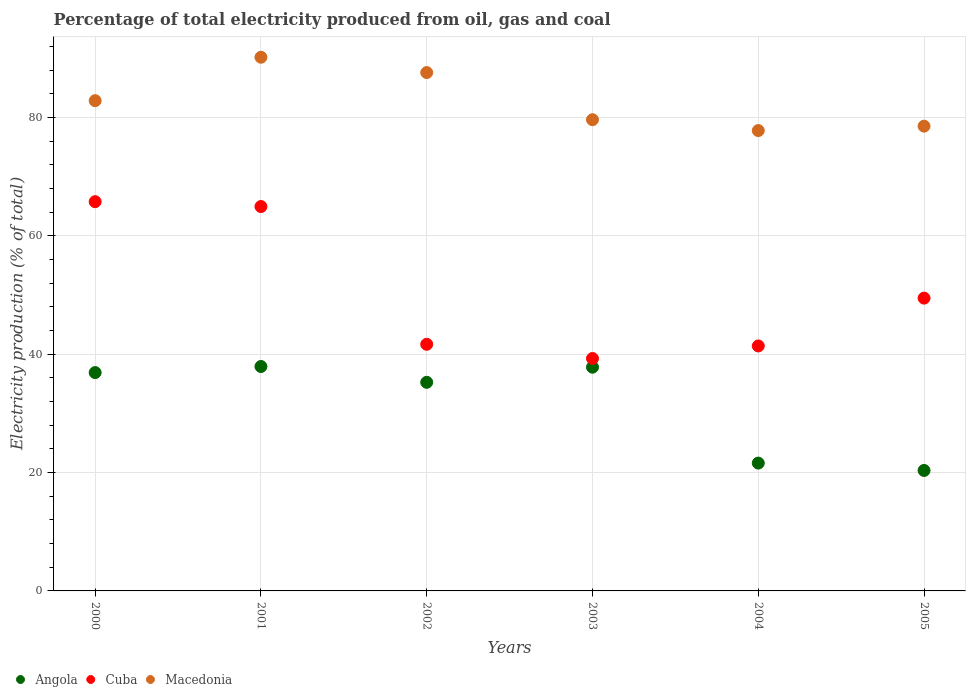How many different coloured dotlines are there?
Give a very brief answer. 3. Is the number of dotlines equal to the number of legend labels?
Make the answer very short. Yes. What is the electricity production in in Macedonia in 2001?
Provide a short and direct response. 90.16. Across all years, what is the maximum electricity production in in Cuba?
Provide a short and direct response. 65.76. Across all years, what is the minimum electricity production in in Cuba?
Make the answer very short. 39.27. In which year was the electricity production in in Cuba maximum?
Offer a terse response. 2000. What is the total electricity production in in Macedonia in the graph?
Offer a terse response. 496.45. What is the difference between the electricity production in in Angola in 2000 and that in 2005?
Provide a succinct answer. 16.53. What is the difference between the electricity production in in Cuba in 2001 and the electricity production in in Macedonia in 2000?
Keep it short and to the point. -17.88. What is the average electricity production in in Angola per year?
Ensure brevity in your answer.  31.63. In the year 2001, what is the difference between the electricity production in in Angola and electricity production in in Cuba?
Make the answer very short. -27.03. In how many years, is the electricity production in in Macedonia greater than 52 %?
Your answer should be very brief. 6. What is the ratio of the electricity production in in Cuba in 2001 to that in 2003?
Give a very brief answer. 1.65. Is the difference between the electricity production in in Angola in 2001 and 2005 greater than the difference between the electricity production in in Cuba in 2001 and 2005?
Ensure brevity in your answer.  Yes. What is the difference between the highest and the second highest electricity production in in Macedonia?
Give a very brief answer. 2.59. What is the difference between the highest and the lowest electricity production in in Macedonia?
Keep it short and to the point. 12.39. Is the sum of the electricity production in in Cuba in 2000 and 2004 greater than the maximum electricity production in in Angola across all years?
Your response must be concise. Yes. Does the electricity production in in Cuba monotonically increase over the years?
Ensure brevity in your answer.  No. Where does the legend appear in the graph?
Provide a short and direct response. Bottom left. How many legend labels are there?
Provide a short and direct response. 3. How are the legend labels stacked?
Offer a terse response. Horizontal. What is the title of the graph?
Make the answer very short. Percentage of total electricity produced from oil, gas and coal. Does "Zambia" appear as one of the legend labels in the graph?
Your response must be concise. No. What is the label or title of the Y-axis?
Your answer should be very brief. Electricity production (% of total). What is the Electricity production (% of total) in Angola in 2000?
Provide a short and direct response. 36.89. What is the Electricity production (% of total) in Cuba in 2000?
Ensure brevity in your answer.  65.76. What is the Electricity production (% of total) of Macedonia in 2000?
Ensure brevity in your answer.  82.82. What is the Electricity production (% of total) in Angola in 2001?
Your answer should be compact. 37.91. What is the Electricity production (% of total) in Cuba in 2001?
Offer a terse response. 64.94. What is the Electricity production (% of total) of Macedonia in 2001?
Your answer should be very brief. 90.16. What is the Electricity production (% of total) in Angola in 2002?
Keep it short and to the point. 35.24. What is the Electricity production (% of total) of Cuba in 2002?
Ensure brevity in your answer.  41.67. What is the Electricity production (% of total) in Macedonia in 2002?
Give a very brief answer. 87.57. What is the Electricity production (% of total) in Angola in 2003?
Your response must be concise. 37.79. What is the Electricity production (% of total) in Cuba in 2003?
Offer a very short reply. 39.27. What is the Electricity production (% of total) of Macedonia in 2003?
Offer a terse response. 79.61. What is the Electricity production (% of total) in Angola in 2004?
Provide a succinct answer. 21.59. What is the Electricity production (% of total) in Cuba in 2004?
Offer a very short reply. 41.38. What is the Electricity production (% of total) in Macedonia in 2004?
Offer a terse response. 77.77. What is the Electricity production (% of total) in Angola in 2005?
Offer a terse response. 20.35. What is the Electricity production (% of total) of Cuba in 2005?
Offer a terse response. 49.47. What is the Electricity production (% of total) in Macedonia in 2005?
Your answer should be compact. 78.52. Across all years, what is the maximum Electricity production (% of total) of Angola?
Provide a succinct answer. 37.91. Across all years, what is the maximum Electricity production (% of total) of Cuba?
Ensure brevity in your answer.  65.76. Across all years, what is the maximum Electricity production (% of total) in Macedonia?
Make the answer very short. 90.16. Across all years, what is the minimum Electricity production (% of total) of Angola?
Keep it short and to the point. 20.35. Across all years, what is the minimum Electricity production (% of total) of Cuba?
Your answer should be compact. 39.27. Across all years, what is the minimum Electricity production (% of total) of Macedonia?
Offer a terse response. 77.77. What is the total Electricity production (% of total) of Angola in the graph?
Offer a very short reply. 189.78. What is the total Electricity production (% of total) of Cuba in the graph?
Offer a very short reply. 302.48. What is the total Electricity production (% of total) of Macedonia in the graph?
Make the answer very short. 496.45. What is the difference between the Electricity production (% of total) of Angola in 2000 and that in 2001?
Provide a succinct answer. -1.03. What is the difference between the Electricity production (% of total) in Cuba in 2000 and that in 2001?
Keep it short and to the point. 0.82. What is the difference between the Electricity production (% of total) in Macedonia in 2000 and that in 2001?
Give a very brief answer. -7.34. What is the difference between the Electricity production (% of total) of Angola in 2000 and that in 2002?
Provide a short and direct response. 1.65. What is the difference between the Electricity production (% of total) of Cuba in 2000 and that in 2002?
Your answer should be very brief. 24.09. What is the difference between the Electricity production (% of total) in Macedonia in 2000 and that in 2002?
Ensure brevity in your answer.  -4.75. What is the difference between the Electricity production (% of total) in Angola in 2000 and that in 2003?
Give a very brief answer. -0.91. What is the difference between the Electricity production (% of total) in Cuba in 2000 and that in 2003?
Your answer should be compact. 26.49. What is the difference between the Electricity production (% of total) of Macedonia in 2000 and that in 2003?
Ensure brevity in your answer.  3.21. What is the difference between the Electricity production (% of total) in Angola in 2000 and that in 2004?
Your response must be concise. 15.29. What is the difference between the Electricity production (% of total) of Cuba in 2000 and that in 2004?
Offer a very short reply. 24.38. What is the difference between the Electricity production (% of total) in Macedonia in 2000 and that in 2004?
Keep it short and to the point. 5.05. What is the difference between the Electricity production (% of total) in Angola in 2000 and that in 2005?
Your response must be concise. 16.53. What is the difference between the Electricity production (% of total) in Cuba in 2000 and that in 2005?
Provide a succinct answer. 16.29. What is the difference between the Electricity production (% of total) in Macedonia in 2000 and that in 2005?
Keep it short and to the point. 4.3. What is the difference between the Electricity production (% of total) in Angola in 2001 and that in 2002?
Keep it short and to the point. 2.67. What is the difference between the Electricity production (% of total) in Cuba in 2001 and that in 2002?
Provide a short and direct response. 23.27. What is the difference between the Electricity production (% of total) in Macedonia in 2001 and that in 2002?
Offer a terse response. 2.59. What is the difference between the Electricity production (% of total) of Angola in 2001 and that in 2003?
Provide a short and direct response. 0.12. What is the difference between the Electricity production (% of total) in Cuba in 2001 and that in 2003?
Offer a very short reply. 25.67. What is the difference between the Electricity production (% of total) in Macedonia in 2001 and that in 2003?
Keep it short and to the point. 10.55. What is the difference between the Electricity production (% of total) of Angola in 2001 and that in 2004?
Offer a terse response. 16.32. What is the difference between the Electricity production (% of total) of Cuba in 2001 and that in 2004?
Keep it short and to the point. 23.55. What is the difference between the Electricity production (% of total) in Macedonia in 2001 and that in 2004?
Your answer should be compact. 12.39. What is the difference between the Electricity production (% of total) in Angola in 2001 and that in 2005?
Ensure brevity in your answer.  17.56. What is the difference between the Electricity production (% of total) in Cuba in 2001 and that in 2005?
Ensure brevity in your answer.  15.47. What is the difference between the Electricity production (% of total) in Macedonia in 2001 and that in 2005?
Provide a short and direct response. 11.64. What is the difference between the Electricity production (% of total) of Angola in 2002 and that in 2003?
Your answer should be very brief. -2.55. What is the difference between the Electricity production (% of total) in Cuba in 2002 and that in 2003?
Make the answer very short. 2.4. What is the difference between the Electricity production (% of total) in Macedonia in 2002 and that in 2003?
Keep it short and to the point. 7.96. What is the difference between the Electricity production (% of total) of Angola in 2002 and that in 2004?
Your answer should be compact. 13.65. What is the difference between the Electricity production (% of total) in Cuba in 2002 and that in 2004?
Ensure brevity in your answer.  0.28. What is the difference between the Electricity production (% of total) of Macedonia in 2002 and that in 2004?
Ensure brevity in your answer.  9.8. What is the difference between the Electricity production (% of total) in Angola in 2002 and that in 2005?
Provide a succinct answer. 14.89. What is the difference between the Electricity production (% of total) in Cuba in 2002 and that in 2005?
Give a very brief answer. -7.8. What is the difference between the Electricity production (% of total) in Macedonia in 2002 and that in 2005?
Provide a succinct answer. 9.05. What is the difference between the Electricity production (% of total) in Angola in 2003 and that in 2004?
Offer a terse response. 16.2. What is the difference between the Electricity production (% of total) of Cuba in 2003 and that in 2004?
Provide a succinct answer. -2.12. What is the difference between the Electricity production (% of total) in Macedonia in 2003 and that in 2004?
Provide a succinct answer. 1.84. What is the difference between the Electricity production (% of total) in Angola in 2003 and that in 2005?
Provide a short and direct response. 17.44. What is the difference between the Electricity production (% of total) of Cuba in 2003 and that in 2005?
Offer a very short reply. -10.2. What is the difference between the Electricity production (% of total) of Macedonia in 2003 and that in 2005?
Keep it short and to the point. 1.09. What is the difference between the Electricity production (% of total) of Angola in 2004 and that in 2005?
Provide a succinct answer. 1.24. What is the difference between the Electricity production (% of total) of Cuba in 2004 and that in 2005?
Your answer should be very brief. -8.08. What is the difference between the Electricity production (% of total) of Macedonia in 2004 and that in 2005?
Ensure brevity in your answer.  -0.75. What is the difference between the Electricity production (% of total) of Angola in 2000 and the Electricity production (% of total) of Cuba in 2001?
Make the answer very short. -28.05. What is the difference between the Electricity production (% of total) of Angola in 2000 and the Electricity production (% of total) of Macedonia in 2001?
Your answer should be very brief. -53.27. What is the difference between the Electricity production (% of total) of Cuba in 2000 and the Electricity production (% of total) of Macedonia in 2001?
Offer a terse response. -24.4. What is the difference between the Electricity production (% of total) in Angola in 2000 and the Electricity production (% of total) in Cuba in 2002?
Give a very brief answer. -4.78. What is the difference between the Electricity production (% of total) in Angola in 2000 and the Electricity production (% of total) in Macedonia in 2002?
Make the answer very short. -50.69. What is the difference between the Electricity production (% of total) in Cuba in 2000 and the Electricity production (% of total) in Macedonia in 2002?
Offer a very short reply. -21.81. What is the difference between the Electricity production (% of total) of Angola in 2000 and the Electricity production (% of total) of Cuba in 2003?
Provide a succinct answer. -2.38. What is the difference between the Electricity production (% of total) of Angola in 2000 and the Electricity production (% of total) of Macedonia in 2003?
Provide a short and direct response. -42.72. What is the difference between the Electricity production (% of total) in Cuba in 2000 and the Electricity production (% of total) in Macedonia in 2003?
Ensure brevity in your answer.  -13.85. What is the difference between the Electricity production (% of total) in Angola in 2000 and the Electricity production (% of total) in Cuba in 2004?
Provide a short and direct response. -4.5. What is the difference between the Electricity production (% of total) in Angola in 2000 and the Electricity production (% of total) in Macedonia in 2004?
Give a very brief answer. -40.89. What is the difference between the Electricity production (% of total) of Cuba in 2000 and the Electricity production (% of total) of Macedonia in 2004?
Offer a terse response. -12.01. What is the difference between the Electricity production (% of total) in Angola in 2000 and the Electricity production (% of total) in Cuba in 2005?
Provide a short and direct response. -12.58. What is the difference between the Electricity production (% of total) of Angola in 2000 and the Electricity production (% of total) of Macedonia in 2005?
Ensure brevity in your answer.  -41.63. What is the difference between the Electricity production (% of total) in Cuba in 2000 and the Electricity production (% of total) in Macedonia in 2005?
Give a very brief answer. -12.76. What is the difference between the Electricity production (% of total) of Angola in 2001 and the Electricity production (% of total) of Cuba in 2002?
Make the answer very short. -3.75. What is the difference between the Electricity production (% of total) in Angola in 2001 and the Electricity production (% of total) in Macedonia in 2002?
Your answer should be compact. -49.66. What is the difference between the Electricity production (% of total) of Cuba in 2001 and the Electricity production (% of total) of Macedonia in 2002?
Make the answer very short. -22.63. What is the difference between the Electricity production (% of total) in Angola in 2001 and the Electricity production (% of total) in Cuba in 2003?
Provide a succinct answer. -1.35. What is the difference between the Electricity production (% of total) of Angola in 2001 and the Electricity production (% of total) of Macedonia in 2003?
Your answer should be compact. -41.7. What is the difference between the Electricity production (% of total) of Cuba in 2001 and the Electricity production (% of total) of Macedonia in 2003?
Your answer should be very brief. -14.67. What is the difference between the Electricity production (% of total) in Angola in 2001 and the Electricity production (% of total) in Cuba in 2004?
Your response must be concise. -3.47. What is the difference between the Electricity production (% of total) of Angola in 2001 and the Electricity production (% of total) of Macedonia in 2004?
Give a very brief answer. -39.86. What is the difference between the Electricity production (% of total) of Cuba in 2001 and the Electricity production (% of total) of Macedonia in 2004?
Offer a terse response. -12.83. What is the difference between the Electricity production (% of total) in Angola in 2001 and the Electricity production (% of total) in Cuba in 2005?
Your response must be concise. -11.55. What is the difference between the Electricity production (% of total) of Angola in 2001 and the Electricity production (% of total) of Macedonia in 2005?
Offer a very short reply. -40.6. What is the difference between the Electricity production (% of total) in Cuba in 2001 and the Electricity production (% of total) in Macedonia in 2005?
Ensure brevity in your answer.  -13.58. What is the difference between the Electricity production (% of total) of Angola in 2002 and the Electricity production (% of total) of Cuba in 2003?
Make the answer very short. -4.03. What is the difference between the Electricity production (% of total) of Angola in 2002 and the Electricity production (% of total) of Macedonia in 2003?
Ensure brevity in your answer.  -44.37. What is the difference between the Electricity production (% of total) of Cuba in 2002 and the Electricity production (% of total) of Macedonia in 2003?
Give a very brief answer. -37.94. What is the difference between the Electricity production (% of total) in Angola in 2002 and the Electricity production (% of total) in Cuba in 2004?
Offer a terse response. -6.14. What is the difference between the Electricity production (% of total) of Angola in 2002 and the Electricity production (% of total) of Macedonia in 2004?
Keep it short and to the point. -42.53. What is the difference between the Electricity production (% of total) in Cuba in 2002 and the Electricity production (% of total) in Macedonia in 2004?
Give a very brief answer. -36.11. What is the difference between the Electricity production (% of total) in Angola in 2002 and the Electricity production (% of total) in Cuba in 2005?
Make the answer very short. -14.22. What is the difference between the Electricity production (% of total) in Angola in 2002 and the Electricity production (% of total) in Macedonia in 2005?
Your answer should be compact. -43.28. What is the difference between the Electricity production (% of total) of Cuba in 2002 and the Electricity production (% of total) of Macedonia in 2005?
Keep it short and to the point. -36.85. What is the difference between the Electricity production (% of total) in Angola in 2003 and the Electricity production (% of total) in Cuba in 2004?
Your response must be concise. -3.59. What is the difference between the Electricity production (% of total) in Angola in 2003 and the Electricity production (% of total) in Macedonia in 2004?
Offer a very short reply. -39.98. What is the difference between the Electricity production (% of total) of Cuba in 2003 and the Electricity production (% of total) of Macedonia in 2004?
Your answer should be very brief. -38.5. What is the difference between the Electricity production (% of total) in Angola in 2003 and the Electricity production (% of total) in Cuba in 2005?
Make the answer very short. -11.67. What is the difference between the Electricity production (% of total) of Angola in 2003 and the Electricity production (% of total) of Macedonia in 2005?
Give a very brief answer. -40.72. What is the difference between the Electricity production (% of total) in Cuba in 2003 and the Electricity production (% of total) in Macedonia in 2005?
Keep it short and to the point. -39.25. What is the difference between the Electricity production (% of total) of Angola in 2004 and the Electricity production (% of total) of Cuba in 2005?
Your answer should be very brief. -27.87. What is the difference between the Electricity production (% of total) in Angola in 2004 and the Electricity production (% of total) in Macedonia in 2005?
Offer a terse response. -56.92. What is the difference between the Electricity production (% of total) in Cuba in 2004 and the Electricity production (% of total) in Macedonia in 2005?
Ensure brevity in your answer.  -37.13. What is the average Electricity production (% of total) in Angola per year?
Ensure brevity in your answer.  31.63. What is the average Electricity production (% of total) in Cuba per year?
Keep it short and to the point. 50.41. What is the average Electricity production (% of total) of Macedonia per year?
Offer a terse response. 82.74. In the year 2000, what is the difference between the Electricity production (% of total) in Angola and Electricity production (% of total) in Cuba?
Provide a short and direct response. -28.87. In the year 2000, what is the difference between the Electricity production (% of total) in Angola and Electricity production (% of total) in Macedonia?
Provide a short and direct response. -45.94. In the year 2000, what is the difference between the Electricity production (% of total) in Cuba and Electricity production (% of total) in Macedonia?
Provide a succinct answer. -17.06. In the year 2001, what is the difference between the Electricity production (% of total) in Angola and Electricity production (% of total) in Cuba?
Provide a short and direct response. -27.03. In the year 2001, what is the difference between the Electricity production (% of total) of Angola and Electricity production (% of total) of Macedonia?
Provide a succinct answer. -52.25. In the year 2001, what is the difference between the Electricity production (% of total) of Cuba and Electricity production (% of total) of Macedonia?
Provide a succinct answer. -25.22. In the year 2002, what is the difference between the Electricity production (% of total) of Angola and Electricity production (% of total) of Cuba?
Your answer should be compact. -6.42. In the year 2002, what is the difference between the Electricity production (% of total) of Angola and Electricity production (% of total) of Macedonia?
Your answer should be compact. -52.33. In the year 2002, what is the difference between the Electricity production (% of total) in Cuba and Electricity production (% of total) in Macedonia?
Offer a very short reply. -45.91. In the year 2003, what is the difference between the Electricity production (% of total) in Angola and Electricity production (% of total) in Cuba?
Your answer should be compact. -1.47. In the year 2003, what is the difference between the Electricity production (% of total) of Angola and Electricity production (% of total) of Macedonia?
Keep it short and to the point. -41.81. In the year 2003, what is the difference between the Electricity production (% of total) in Cuba and Electricity production (% of total) in Macedonia?
Make the answer very short. -40.34. In the year 2004, what is the difference between the Electricity production (% of total) in Angola and Electricity production (% of total) in Cuba?
Provide a short and direct response. -19.79. In the year 2004, what is the difference between the Electricity production (% of total) of Angola and Electricity production (% of total) of Macedonia?
Your answer should be very brief. -56.18. In the year 2004, what is the difference between the Electricity production (% of total) of Cuba and Electricity production (% of total) of Macedonia?
Your response must be concise. -36.39. In the year 2005, what is the difference between the Electricity production (% of total) in Angola and Electricity production (% of total) in Cuba?
Make the answer very short. -29.11. In the year 2005, what is the difference between the Electricity production (% of total) in Angola and Electricity production (% of total) in Macedonia?
Your response must be concise. -58.17. In the year 2005, what is the difference between the Electricity production (% of total) in Cuba and Electricity production (% of total) in Macedonia?
Offer a very short reply. -29.05. What is the ratio of the Electricity production (% of total) in Angola in 2000 to that in 2001?
Offer a terse response. 0.97. What is the ratio of the Electricity production (% of total) of Cuba in 2000 to that in 2001?
Provide a succinct answer. 1.01. What is the ratio of the Electricity production (% of total) in Macedonia in 2000 to that in 2001?
Offer a very short reply. 0.92. What is the ratio of the Electricity production (% of total) of Angola in 2000 to that in 2002?
Give a very brief answer. 1.05. What is the ratio of the Electricity production (% of total) in Cuba in 2000 to that in 2002?
Your answer should be very brief. 1.58. What is the ratio of the Electricity production (% of total) of Macedonia in 2000 to that in 2002?
Offer a terse response. 0.95. What is the ratio of the Electricity production (% of total) of Cuba in 2000 to that in 2003?
Offer a terse response. 1.67. What is the ratio of the Electricity production (% of total) in Macedonia in 2000 to that in 2003?
Offer a terse response. 1.04. What is the ratio of the Electricity production (% of total) of Angola in 2000 to that in 2004?
Offer a terse response. 1.71. What is the ratio of the Electricity production (% of total) in Cuba in 2000 to that in 2004?
Offer a terse response. 1.59. What is the ratio of the Electricity production (% of total) in Macedonia in 2000 to that in 2004?
Offer a very short reply. 1.06. What is the ratio of the Electricity production (% of total) of Angola in 2000 to that in 2005?
Your answer should be compact. 1.81. What is the ratio of the Electricity production (% of total) of Cuba in 2000 to that in 2005?
Your response must be concise. 1.33. What is the ratio of the Electricity production (% of total) of Macedonia in 2000 to that in 2005?
Provide a short and direct response. 1.05. What is the ratio of the Electricity production (% of total) of Angola in 2001 to that in 2002?
Provide a succinct answer. 1.08. What is the ratio of the Electricity production (% of total) of Cuba in 2001 to that in 2002?
Provide a short and direct response. 1.56. What is the ratio of the Electricity production (% of total) in Macedonia in 2001 to that in 2002?
Your response must be concise. 1.03. What is the ratio of the Electricity production (% of total) of Cuba in 2001 to that in 2003?
Offer a terse response. 1.65. What is the ratio of the Electricity production (% of total) of Macedonia in 2001 to that in 2003?
Make the answer very short. 1.13. What is the ratio of the Electricity production (% of total) in Angola in 2001 to that in 2004?
Ensure brevity in your answer.  1.76. What is the ratio of the Electricity production (% of total) in Cuba in 2001 to that in 2004?
Provide a succinct answer. 1.57. What is the ratio of the Electricity production (% of total) of Macedonia in 2001 to that in 2004?
Provide a succinct answer. 1.16. What is the ratio of the Electricity production (% of total) of Angola in 2001 to that in 2005?
Make the answer very short. 1.86. What is the ratio of the Electricity production (% of total) in Cuba in 2001 to that in 2005?
Ensure brevity in your answer.  1.31. What is the ratio of the Electricity production (% of total) of Macedonia in 2001 to that in 2005?
Offer a terse response. 1.15. What is the ratio of the Electricity production (% of total) of Angola in 2002 to that in 2003?
Offer a very short reply. 0.93. What is the ratio of the Electricity production (% of total) of Cuba in 2002 to that in 2003?
Make the answer very short. 1.06. What is the ratio of the Electricity production (% of total) in Angola in 2002 to that in 2004?
Make the answer very short. 1.63. What is the ratio of the Electricity production (% of total) of Cuba in 2002 to that in 2004?
Provide a short and direct response. 1.01. What is the ratio of the Electricity production (% of total) of Macedonia in 2002 to that in 2004?
Give a very brief answer. 1.13. What is the ratio of the Electricity production (% of total) in Angola in 2002 to that in 2005?
Provide a succinct answer. 1.73. What is the ratio of the Electricity production (% of total) of Cuba in 2002 to that in 2005?
Provide a succinct answer. 0.84. What is the ratio of the Electricity production (% of total) of Macedonia in 2002 to that in 2005?
Provide a short and direct response. 1.12. What is the ratio of the Electricity production (% of total) of Angola in 2003 to that in 2004?
Give a very brief answer. 1.75. What is the ratio of the Electricity production (% of total) of Cuba in 2003 to that in 2004?
Offer a very short reply. 0.95. What is the ratio of the Electricity production (% of total) in Macedonia in 2003 to that in 2004?
Provide a succinct answer. 1.02. What is the ratio of the Electricity production (% of total) of Angola in 2003 to that in 2005?
Provide a succinct answer. 1.86. What is the ratio of the Electricity production (% of total) of Cuba in 2003 to that in 2005?
Your response must be concise. 0.79. What is the ratio of the Electricity production (% of total) of Macedonia in 2003 to that in 2005?
Provide a succinct answer. 1.01. What is the ratio of the Electricity production (% of total) of Angola in 2004 to that in 2005?
Keep it short and to the point. 1.06. What is the ratio of the Electricity production (% of total) of Cuba in 2004 to that in 2005?
Ensure brevity in your answer.  0.84. What is the difference between the highest and the second highest Electricity production (% of total) in Angola?
Offer a terse response. 0.12. What is the difference between the highest and the second highest Electricity production (% of total) in Cuba?
Give a very brief answer. 0.82. What is the difference between the highest and the second highest Electricity production (% of total) of Macedonia?
Your response must be concise. 2.59. What is the difference between the highest and the lowest Electricity production (% of total) of Angola?
Make the answer very short. 17.56. What is the difference between the highest and the lowest Electricity production (% of total) of Cuba?
Offer a terse response. 26.49. What is the difference between the highest and the lowest Electricity production (% of total) in Macedonia?
Provide a succinct answer. 12.39. 